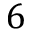<formula> <loc_0><loc_0><loc_500><loc_500>6</formula> 